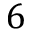<formula> <loc_0><loc_0><loc_500><loc_500>6</formula> 